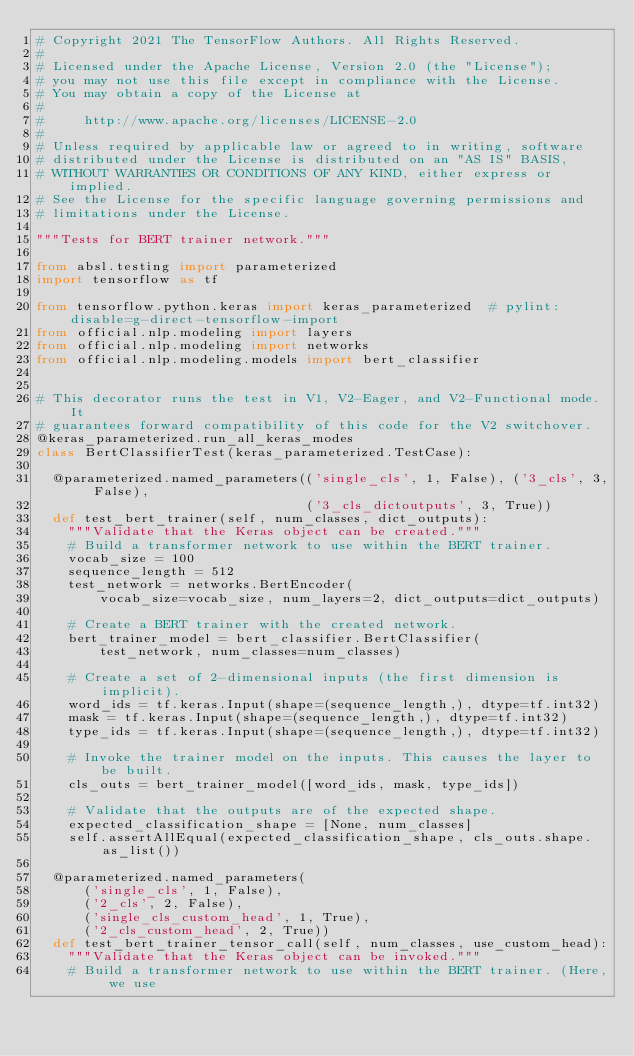Convert code to text. <code><loc_0><loc_0><loc_500><loc_500><_Python_># Copyright 2021 The TensorFlow Authors. All Rights Reserved.
#
# Licensed under the Apache License, Version 2.0 (the "License");
# you may not use this file except in compliance with the License.
# You may obtain a copy of the License at
#
#     http://www.apache.org/licenses/LICENSE-2.0
#
# Unless required by applicable law or agreed to in writing, software
# distributed under the License is distributed on an "AS IS" BASIS,
# WITHOUT WARRANTIES OR CONDITIONS OF ANY KIND, either express or implied.
# See the License for the specific language governing permissions and
# limitations under the License.

"""Tests for BERT trainer network."""

from absl.testing import parameterized
import tensorflow as tf

from tensorflow.python.keras import keras_parameterized  # pylint: disable=g-direct-tensorflow-import
from official.nlp.modeling import layers
from official.nlp.modeling import networks
from official.nlp.modeling.models import bert_classifier


# This decorator runs the test in V1, V2-Eager, and V2-Functional mode. It
# guarantees forward compatibility of this code for the V2 switchover.
@keras_parameterized.run_all_keras_modes
class BertClassifierTest(keras_parameterized.TestCase):

  @parameterized.named_parameters(('single_cls', 1, False), ('3_cls', 3, False),
                                  ('3_cls_dictoutputs', 3, True))
  def test_bert_trainer(self, num_classes, dict_outputs):
    """Validate that the Keras object can be created."""
    # Build a transformer network to use within the BERT trainer.
    vocab_size = 100
    sequence_length = 512
    test_network = networks.BertEncoder(
        vocab_size=vocab_size, num_layers=2, dict_outputs=dict_outputs)

    # Create a BERT trainer with the created network.
    bert_trainer_model = bert_classifier.BertClassifier(
        test_network, num_classes=num_classes)

    # Create a set of 2-dimensional inputs (the first dimension is implicit).
    word_ids = tf.keras.Input(shape=(sequence_length,), dtype=tf.int32)
    mask = tf.keras.Input(shape=(sequence_length,), dtype=tf.int32)
    type_ids = tf.keras.Input(shape=(sequence_length,), dtype=tf.int32)

    # Invoke the trainer model on the inputs. This causes the layer to be built.
    cls_outs = bert_trainer_model([word_ids, mask, type_ids])

    # Validate that the outputs are of the expected shape.
    expected_classification_shape = [None, num_classes]
    self.assertAllEqual(expected_classification_shape, cls_outs.shape.as_list())

  @parameterized.named_parameters(
      ('single_cls', 1, False),
      ('2_cls', 2, False),
      ('single_cls_custom_head', 1, True),
      ('2_cls_custom_head', 2, True))
  def test_bert_trainer_tensor_call(self, num_classes, use_custom_head):
    """Validate that the Keras object can be invoked."""
    # Build a transformer network to use within the BERT trainer. (Here, we use</code> 